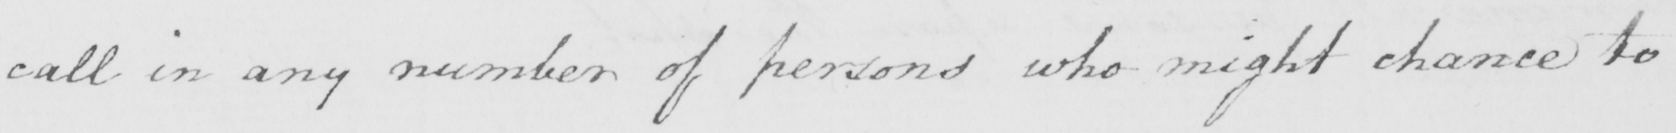Transcribe the text shown in this historical manuscript line. call in any number of persons who might chance to 